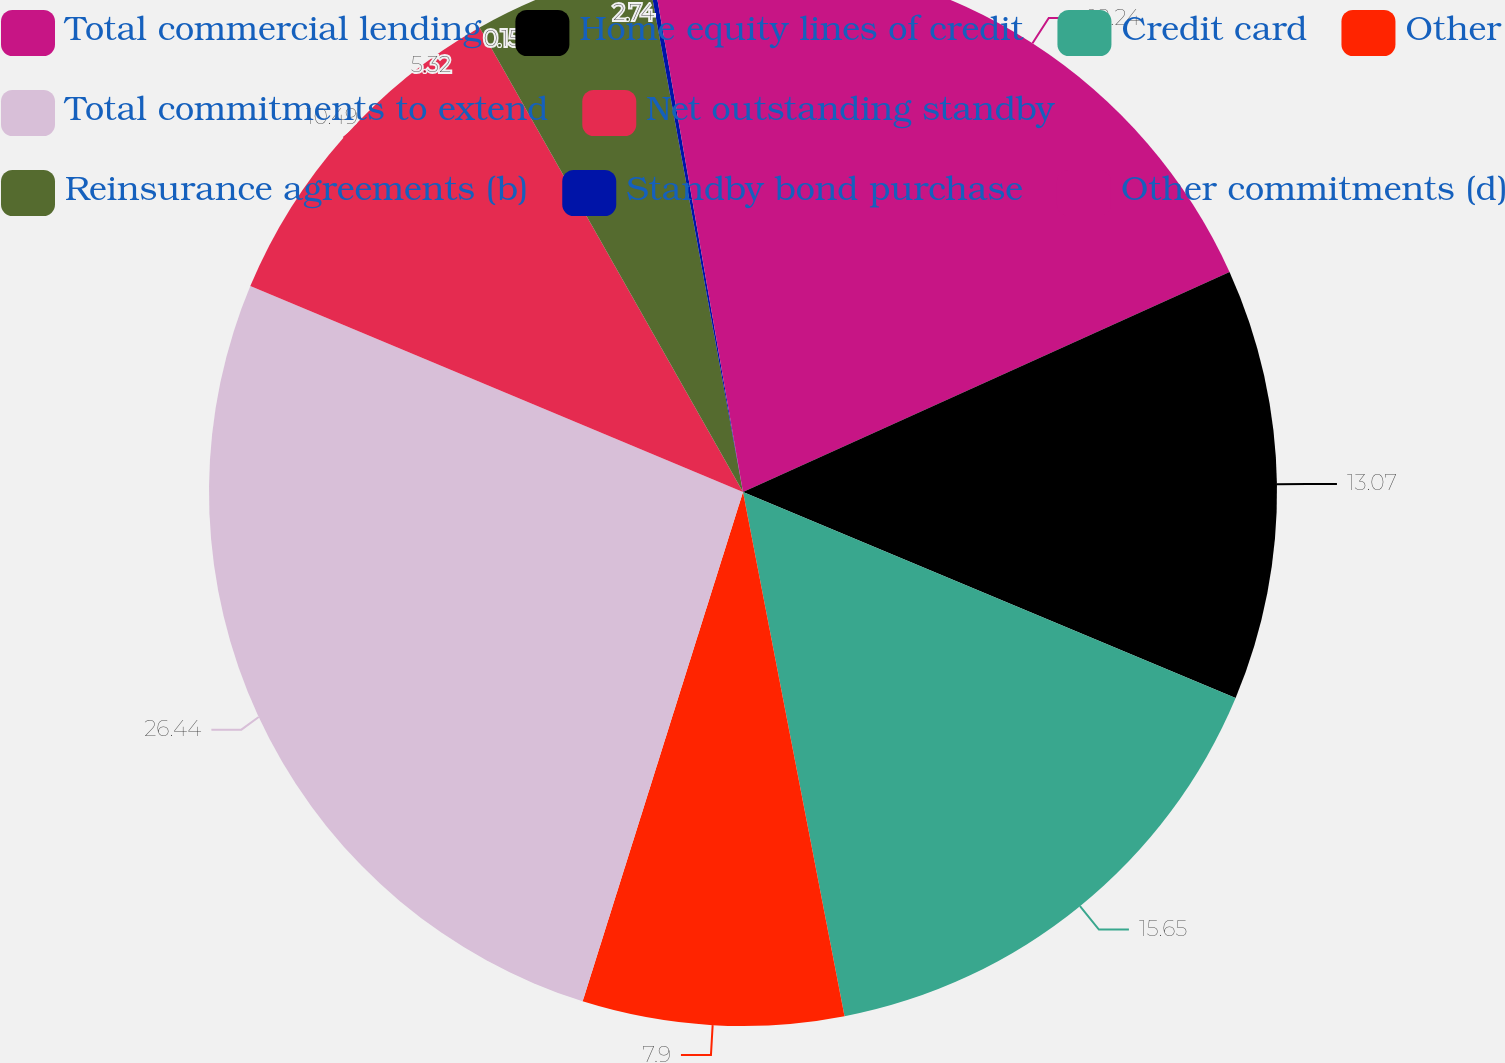<chart> <loc_0><loc_0><loc_500><loc_500><pie_chart><fcel>Total commercial lending<fcel>Home equity lines of credit<fcel>Credit card<fcel>Other<fcel>Total commitments to extend<fcel>Net outstanding standby<fcel>Reinsurance agreements (b)<fcel>Standby bond purchase<fcel>Other commitments (d)<nl><fcel>18.24%<fcel>13.07%<fcel>15.65%<fcel>7.9%<fcel>26.45%<fcel>10.49%<fcel>5.32%<fcel>0.15%<fcel>2.74%<nl></chart> 